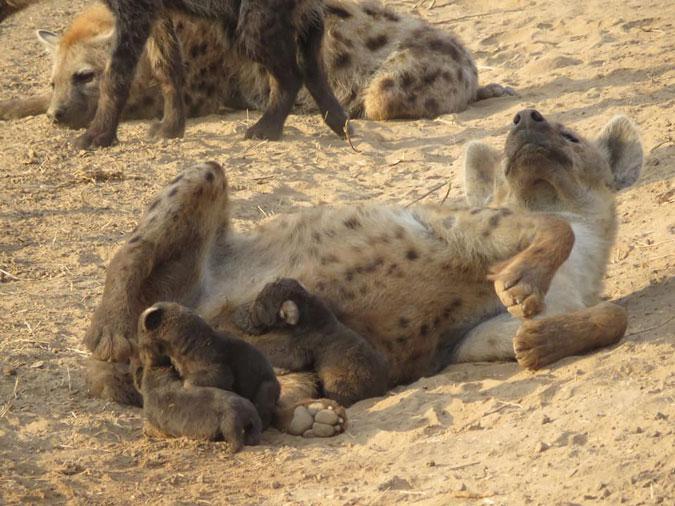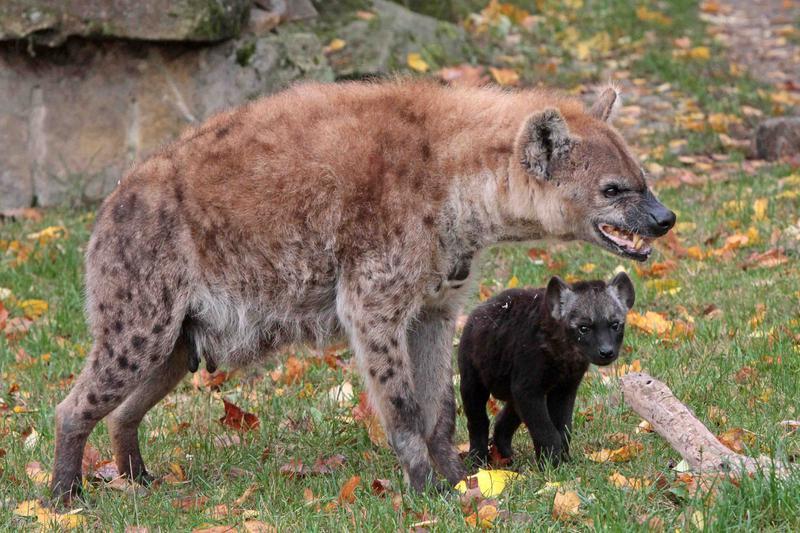The first image is the image on the left, the second image is the image on the right. For the images displayed, is the sentence "One image includes a dark hyena pup and an adult hyena, and shows their heads one above the other." factually correct? Answer yes or no. Yes. The first image is the image on the left, the second image is the image on the right. Considering the images on both sides, is "The right image contains exactly two hyenas." valid? Answer yes or no. Yes. 